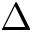<formula> <loc_0><loc_0><loc_500><loc_500>\Delta</formula> 